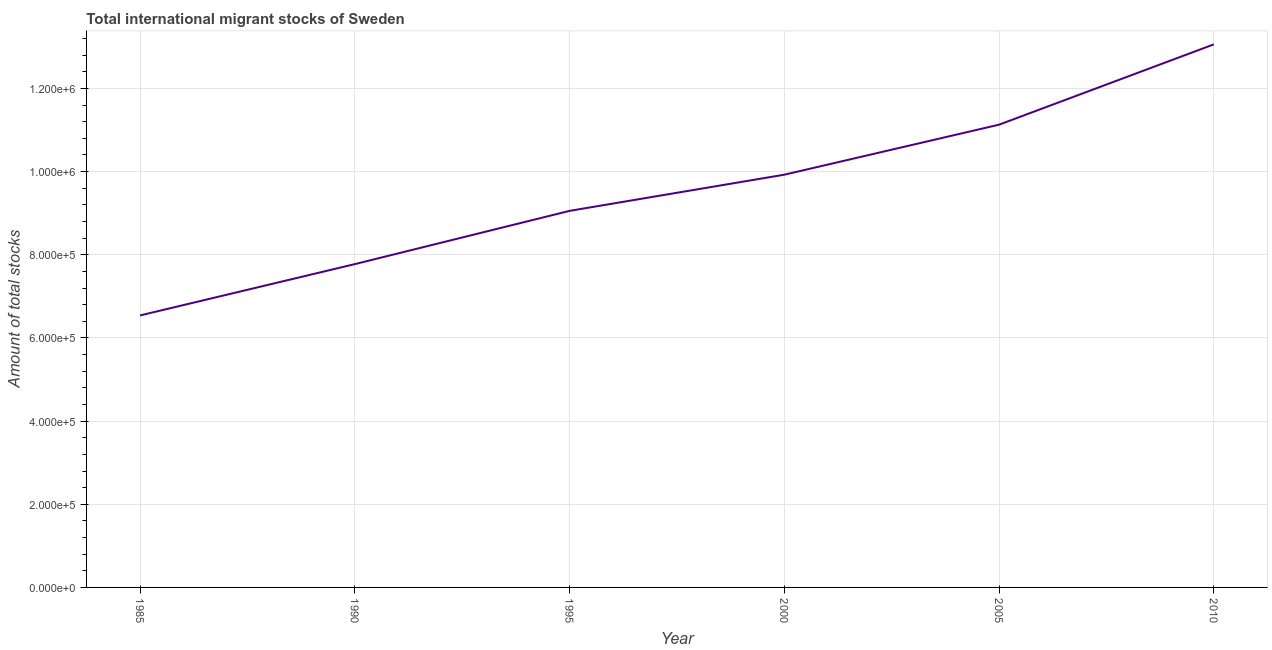What is the total number of international migrant stock in 1990?
Your response must be concise. 7.78e+05. Across all years, what is the maximum total number of international migrant stock?
Make the answer very short. 1.31e+06. Across all years, what is the minimum total number of international migrant stock?
Keep it short and to the point. 6.54e+05. In which year was the total number of international migrant stock maximum?
Offer a terse response. 2010. In which year was the total number of international migrant stock minimum?
Ensure brevity in your answer.  1985. What is the sum of the total number of international migrant stock?
Offer a terse response. 5.75e+06. What is the difference between the total number of international migrant stock in 1990 and 1995?
Give a very brief answer. -1.28e+05. What is the average total number of international migrant stock per year?
Make the answer very short. 9.58e+05. What is the median total number of international migrant stock?
Make the answer very short. 9.49e+05. Do a majority of the years between 2000 and 2005 (inclusive) have total number of international migrant stock greater than 760000 ?
Your answer should be compact. Yes. What is the ratio of the total number of international migrant stock in 2005 to that in 2010?
Provide a short and direct response. 0.85. Is the total number of international migrant stock in 2000 less than that in 2010?
Provide a short and direct response. Yes. What is the difference between the highest and the second highest total number of international migrant stock?
Keep it short and to the point. 1.93e+05. What is the difference between the highest and the lowest total number of international migrant stock?
Give a very brief answer. 6.52e+05. In how many years, is the total number of international migrant stock greater than the average total number of international migrant stock taken over all years?
Your answer should be compact. 3. How many lines are there?
Provide a succinct answer. 1. Are the values on the major ticks of Y-axis written in scientific E-notation?
Offer a terse response. Yes. Does the graph contain grids?
Offer a terse response. Yes. What is the title of the graph?
Keep it short and to the point. Total international migrant stocks of Sweden. What is the label or title of the Y-axis?
Your response must be concise. Amount of total stocks. What is the Amount of total stocks in 1985?
Provide a short and direct response. 6.54e+05. What is the Amount of total stocks of 1990?
Offer a very short reply. 7.78e+05. What is the Amount of total stocks of 1995?
Your response must be concise. 9.06e+05. What is the Amount of total stocks of 2000?
Ensure brevity in your answer.  9.93e+05. What is the Amount of total stocks in 2005?
Keep it short and to the point. 1.11e+06. What is the Amount of total stocks in 2010?
Offer a terse response. 1.31e+06. What is the difference between the Amount of total stocks in 1985 and 1990?
Your answer should be very brief. -1.23e+05. What is the difference between the Amount of total stocks in 1985 and 1995?
Offer a very short reply. -2.51e+05. What is the difference between the Amount of total stocks in 1985 and 2000?
Make the answer very short. -3.38e+05. What is the difference between the Amount of total stocks in 1985 and 2005?
Provide a succinct answer. -4.59e+05. What is the difference between the Amount of total stocks in 1985 and 2010?
Your answer should be very brief. -6.52e+05. What is the difference between the Amount of total stocks in 1990 and 1995?
Your answer should be compact. -1.28e+05. What is the difference between the Amount of total stocks in 1990 and 2000?
Your answer should be compact. -2.15e+05. What is the difference between the Amount of total stocks in 1990 and 2005?
Provide a short and direct response. -3.35e+05. What is the difference between the Amount of total stocks in 1990 and 2010?
Your answer should be very brief. -5.28e+05. What is the difference between the Amount of total stocks in 1995 and 2000?
Provide a short and direct response. -8.70e+04. What is the difference between the Amount of total stocks in 1995 and 2005?
Offer a terse response. -2.07e+05. What is the difference between the Amount of total stocks in 1995 and 2010?
Give a very brief answer. -4.00e+05. What is the difference between the Amount of total stocks in 2000 and 2005?
Provide a short and direct response. -1.20e+05. What is the difference between the Amount of total stocks in 2000 and 2010?
Ensure brevity in your answer.  -3.13e+05. What is the difference between the Amount of total stocks in 2005 and 2010?
Ensure brevity in your answer.  -1.93e+05. What is the ratio of the Amount of total stocks in 1985 to that in 1990?
Provide a short and direct response. 0.84. What is the ratio of the Amount of total stocks in 1985 to that in 1995?
Your answer should be compact. 0.72. What is the ratio of the Amount of total stocks in 1985 to that in 2000?
Offer a terse response. 0.66. What is the ratio of the Amount of total stocks in 1985 to that in 2005?
Your answer should be very brief. 0.59. What is the ratio of the Amount of total stocks in 1985 to that in 2010?
Ensure brevity in your answer.  0.5. What is the ratio of the Amount of total stocks in 1990 to that in 1995?
Your response must be concise. 0.86. What is the ratio of the Amount of total stocks in 1990 to that in 2000?
Your answer should be compact. 0.78. What is the ratio of the Amount of total stocks in 1990 to that in 2005?
Give a very brief answer. 0.7. What is the ratio of the Amount of total stocks in 1990 to that in 2010?
Your answer should be compact. 0.59. What is the ratio of the Amount of total stocks in 1995 to that in 2000?
Provide a short and direct response. 0.91. What is the ratio of the Amount of total stocks in 1995 to that in 2005?
Your answer should be very brief. 0.81. What is the ratio of the Amount of total stocks in 1995 to that in 2010?
Your answer should be compact. 0.69. What is the ratio of the Amount of total stocks in 2000 to that in 2005?
Your response must be concise. 0.89. What is the ratio of the Amount of total stocks in 2000 to that in 2010?
Your response must be concise. 0.76. What is the ratio of the Amount of total stocks in 2005 to that in 2010?
Offer a terse response. 0.85. 